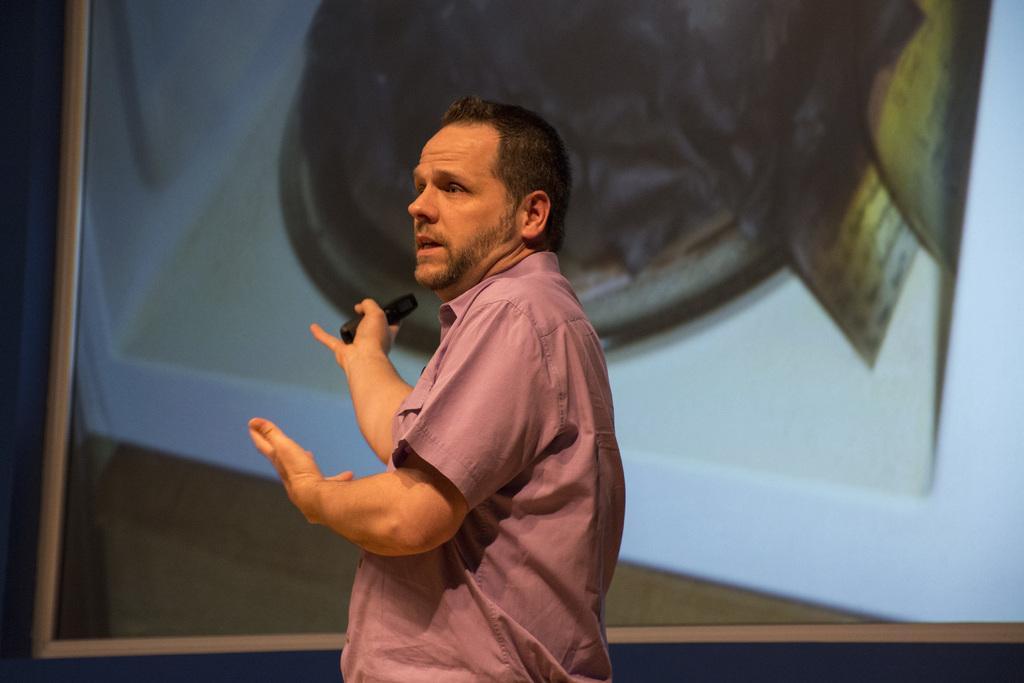Describe this image in one or two sentences. In this picture there is a man in the center of the image and there is a projector screen in the background area of the image. 